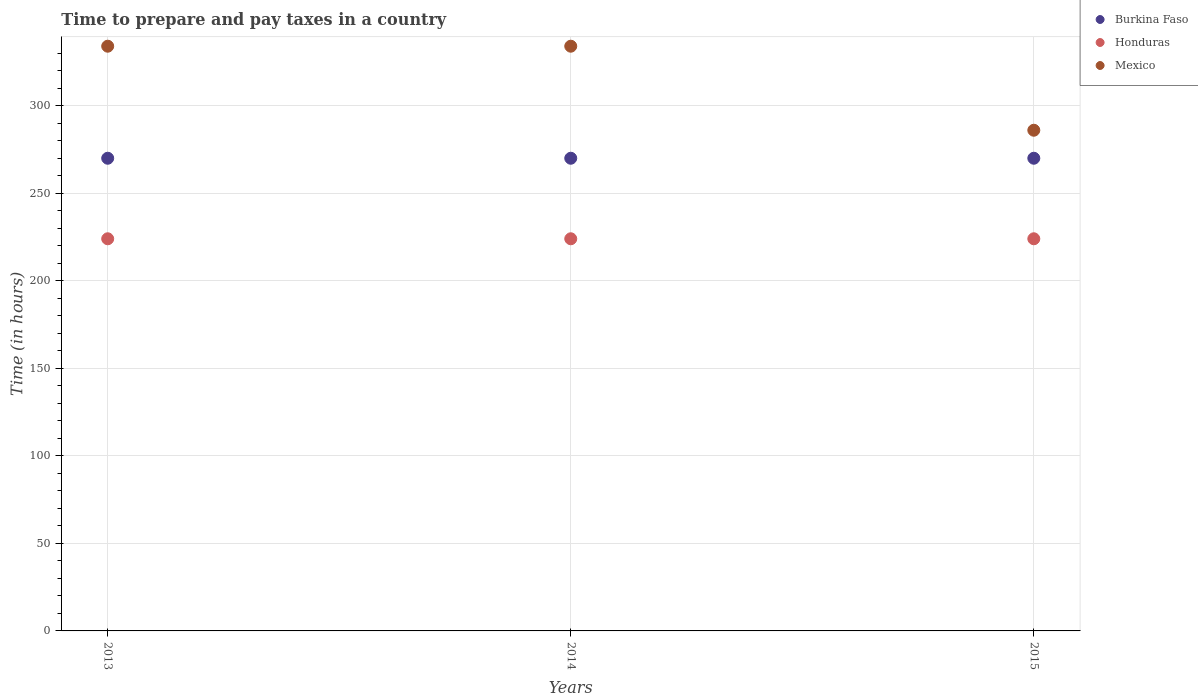How many different coloured dotlines are there?
Offer a very short reply. 3. What is the number of hours required to prepare and pay taxes in Honduras in 2013?
Provide a short and direct response. 224. Across all years, what is the maximum number of hours required to prepare and pay taxes in Burkina Faso?
Give a very brief answer. 270. Across all years, what is the minimum number of hours required to prepare and pay taxes in Honduras?
Ensure brevity in your answer.  224. In which year was the number of hours required to prepare and pay taxes in Mexico minimum?
Your response must be concise. 2015. What is the total number of hours required to prepare and pay taxes in Mexico in the graph?
Make the answer very short. 954. What is the difference between the number of hours required to prepare and pay taxes in Honduras in 2013 and that in 2014?
Ensure brevity in your answer.  0. What is the difference between the number of hours required to prepare and pay taxes in Mexico in 2013 and the number of hours required to prepare and pay taxes in Burkina Faso in 2014?
Give a very brief answer. 64. What is the average number of hours required to prepare and pay taxes in Mexico per year?
Offer a very short reply. 318. In the year 2014, what is the difference between the number of hours required to prepare and pay taxes in Honduras and number of hours required to prepare and pay taxes in Mexico?
Your answer should be very brief. -110. In how many years, is the number of hours required to prepare and pay taxes in Honduras greater than 290 hours?
Your answer should be very brief. 0. Is the difference between the number of hours required to prepare and pay taxes in Honduras in 2013 and 2014 greater than the difference between the number of hours required to prepare and pay taxes in Mexico in 2013 and 2014?
Give a very brief answer. No. What is the difference between the highest and the second highest number of hours required to prepare and pay taxes in Honduras?
Your answer should be compact. 0. Is the number of hours required to prepare and pay taxes in Honduras strictly greater than the number of hours required to prepare and pay taxes in Mexico over the years?
Ensure brevity in your answer.  No. How many dotlines are there?
Offer a terse response. 3. Where does the legend appear in the graph?
Make the answer very short. Top right. How are the legend labels stacked?
Provide a short and direct response. Vertical. What is the title of the graph?
Provide a succinct answer. Time to prepare and pay taxes in a country. Does "Kazakhstan" appear as one of the legend labels in the graph?
Give a very brief answer. No. What is the label or title of the Y-axis?
Provide a short and direct response. Time (in hours). What is the Time (in hours) in Burkina Faso in 2013?
Make the answer very short. 270. What is the Time (in hours) in Honduras in 2013?
Your response must be concise. 224. What is the Time (in hours) in Mexico in 2013?
Provide a succinct answer. 334. What is the Time (in hours) in Burkina Faso in 2014?
Your answer should be compact. 270. What is the Time (in hours) of Honduras in 2014?
Your response must be concise. 224. What is the Time (in hours) of Mexico in 2014?
Make the answer very short. 334. What is the Time (in hours) of Burkina Faso in 2015?
Keep it short and to the point. 270. What is the Time (in hours) in Honduras in 2015?
Give a very brief answer. 224. What is the Time (in hours) in Mexico in 2015?
Give a very brief answer. 286. Across all years, what is the maximum Time (in hours) in Burkina Faso?
Your answer should be very brief. 270. Across all years, what is the maximum Time (in hours) in Honduras?
Ensure brevity in your answer.  224. Across all years, what is the maximum Time (in hours) of Mexico?
Keep it short and to the point. 334. Across all years, what is the minimum Time (in hours) of Burkina Faso?
Provide a succinct answer. 270. Across all years, what is the minimum Time (in hours) in Honduras?
Offer a terse response. 224. Across all years, what is the minimum Time (in hours) of Mexico?
Offer a very short reply. 286. What is the total Time (in hours) of Burkina Faso in the graph?
Give a very brief answer. 810. What is the total Time (in hours) of Honduras in the graph?
Provide a short and direct response. 672. What is the total Time (in hours) in Mexico in the graph?
Ensure brevity in your answer.  954. What is the difference between the Time (in hours) in Honduras in 2013 and that in 2015?
Ensure brevity in your answer.  0. What is the difference between the Time (in hours) of Mexico in 2013 and that in 2015?
Your response must be concise. 48. What is the difference between the Time (in hours) of Burkina Faso in 2014 and that in 2015?
Offer a terse response. 0. What is the difference between the Time (in hours) in Burkina Faso in 2013 and the Time (in hours) in Honduras in 2014?
Provide a short and direct response. 46. What is the difference between the Time (in hours) in Burkina Faso in 2013 and the Time (in hours) in Mexico in 2014?
Offer a very short reply. -64. What is the difference between the Time (in hours) of Honduras in 2013 and the Time (in hours) of Mexico in 2014?
Your answer should be compact. -110. What is the difference between the Time (in hours) of Burkina Faso in 2013 and the Time (in hours) of Mexico in 2015?
Offer a terse response. -16. What is the difference between the Time (in hours) of Honduras in 2013 and the Time (in hours) of Mexico in 2015?
Offer a very short reply. -62. What is the difference between the Time (in hours) of Burkina Faso in 2014 and the Time (in hours) of Mexico in 2015?
Your answer should be compact. -16. What is the difference between the Time (in hours) of Honduras in 2014 and the Time (in hours) of Mexico in 2015?
Your answer should be compact. -62. What is the average Time (in hours) in Burkina Faso per year?
Provide a short and direct response. 270. What is the average Time (in hours) of Honduras per year?
Your answer should be very brief. 224. What is the average Time (in hours) of Mexico per year?
Keep it short and to the point. 318. In the year 2013, what is the difference between the Time (in hours) of Burkina Faso and Time (in hours) of Honduras?
Keep it short and to the point. 46. In the year 2013, what is the difference between the Time (in hours) in Burkina Faso and Time (in hours) in Mexico?
Your response must be concise. -64. In the year 2013, what is the difference between the Time (in hours) of Honduras and Time (in hours) of Mexico?
Your answer should be compact. -110. In the year 2014, what is the difference between the Time (in hours) in Burkina Faso and Time (in hours) in Mexico?
Provide a succinct answer. -64. In the year 2014, what is the difference between the Time (in hours) in Honduras and Time (in hours) in Mexico?
Provide a short and direct response. -110. In the year 2015, what is the difference between the Time (in hours) of Burkina Faso and Time (in hours) of Honduras?
Offer a very short reply. 46. In the year 2015, what is the difference between the Time (in hours) in Honduras and Time (in hours) in Mexico?
Keep it short and to the point. -62. What is the ratio of the Time (in hours) of Honduras in 2013 to that in 2014?
Your response must be concise. 1. What is the ratio of the Time (in hours) in Burkina Faso in 2013 to that in 2015?
Make the answer very short. 1. What is the ratio of the Time (in hours) in Honduras in 2013 to that in 2015?
Make the answer very short. 1. What is the ratio of the Time (in hours) of Mexico in 2013 to that in 2015?
Provide a short and direct response. 1.17. What is the ratio of the Time (in hours) in Honduras in 2014 to that in 2015?
Provide a succinct answer. 1. What is the ratio of the Time (in hours) of Mexico in 2014 to that in 2015?
Your response must be concise. 1.17. What is the difference between the highest and the second highest Time (in hours) of Burkina Faso?
Your response must be concise. 0. What is the difference between the highest and the second highest Time (in hours) in Honduras?
Your response must be concise. 0. What is the difference between the highest and the lowest Time (in hours) of Honduras?
Your answer should be compact. 0. What is the difference between the highest and the lowest Time (in hours) in Mexico?
Your answer should be compact. 48. 